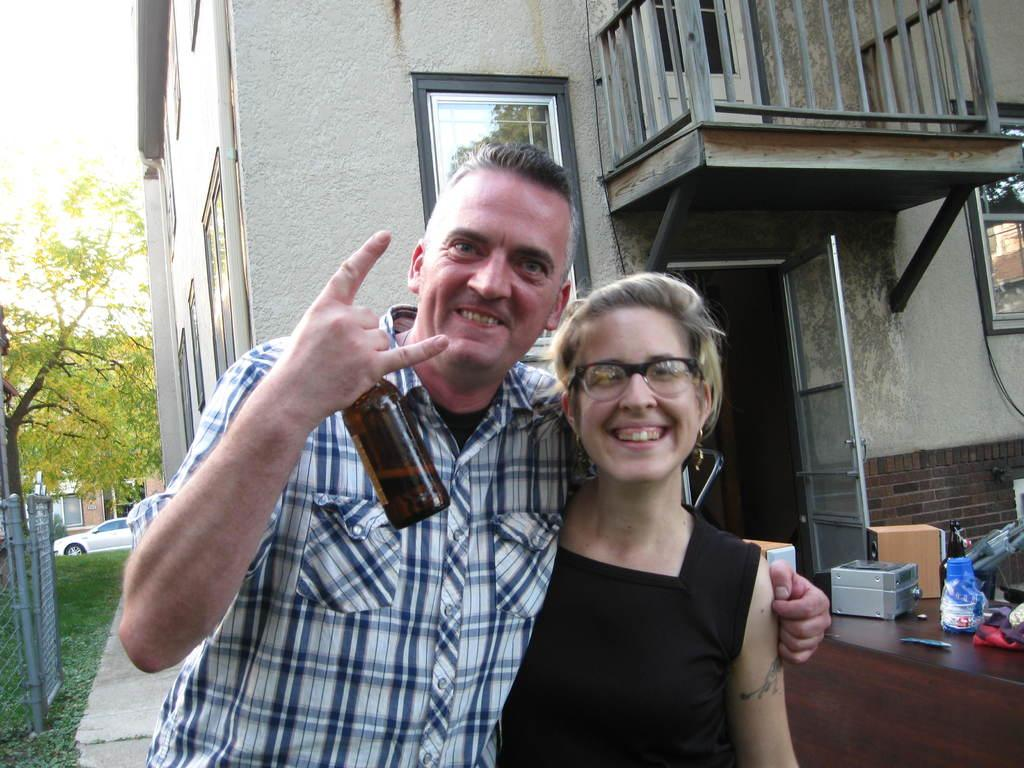How many people are present in the image? There is a man and a woman present in the image. What is the man holding in the image? The man is holding a bottle. What can be seen in the background of the image? There is a building, a tree, vehicles, and a fence in the background of the image. What type of ornament is hanging from the stem of the tree in the image? There is no ornament hanging from the stem of the tree in the image, as there is no tree with a stem present. 